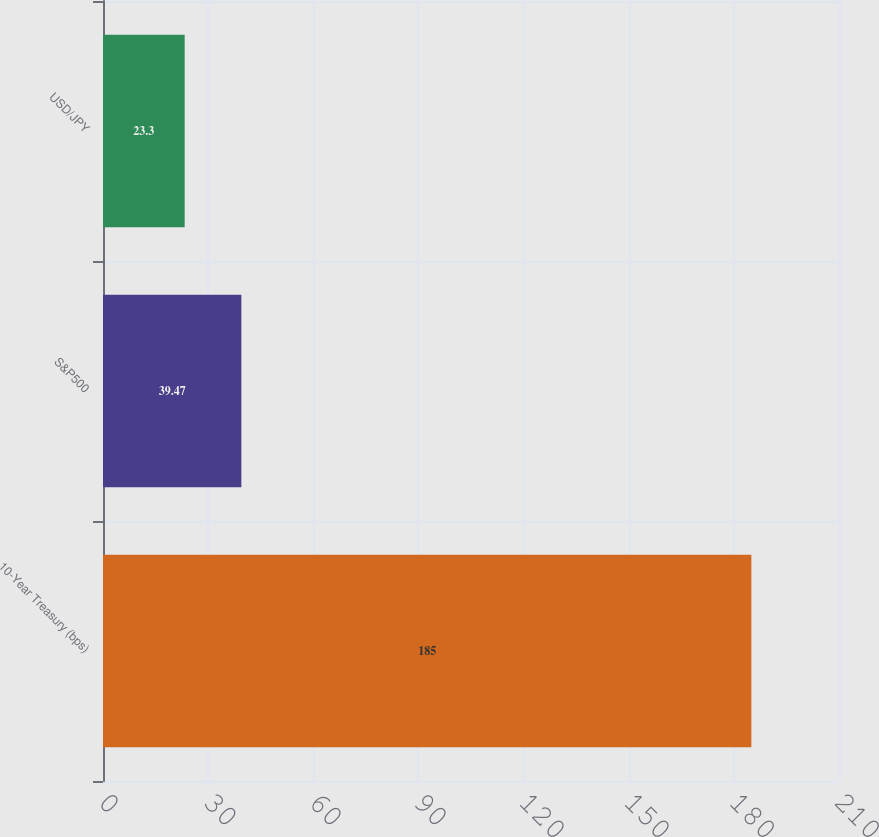Convert chart. <chart><loc_0><loc_0><loc_500><loc_500><bar_chart><fcel>10-Year Treasury (bps)<fcel>S&P500<fcel>USD/JPY<nl><fcel>185<fcel>39.47<fcel>23.3<nl></chart> 